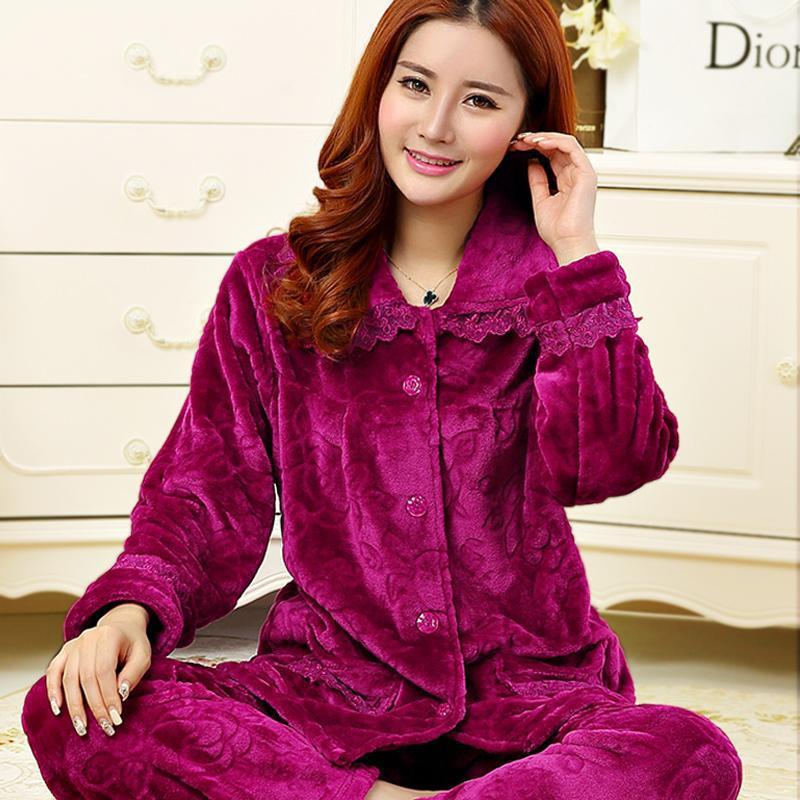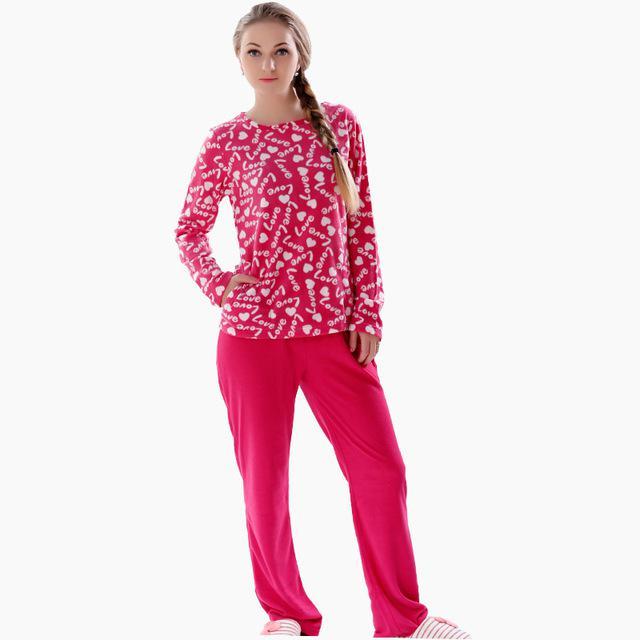The first image is the image on the left, the second image is the image on the right. Analyze the images presented: Is the assertion "There is 1 or more woman modeling pajama's." valid? Answer yes or no. Yes. 